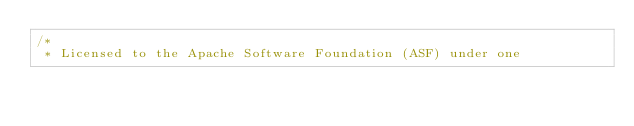Convert code to text. <code><loc_0><loc_0><loc_500><loc_500><_Scala_>/*
 * Licensed to the Apache Software Foundation (ASF) under one</code> 